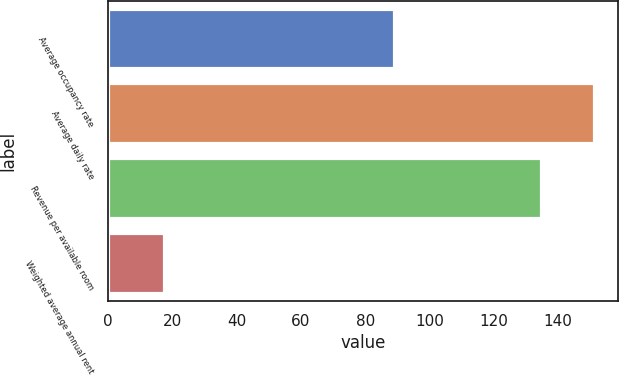Convert chart. <chart><loc_0><loc_0><loc_500><loc_500><bar_chart><fcel>Average occupancy rate<fcel>Average daily rate<fcel>Revenue per available room<fcel>Weighted average annual rent<nl><fcel>89.1<fcel>151.22<fcel>134.81<fcel>17.32<nl></chart> 